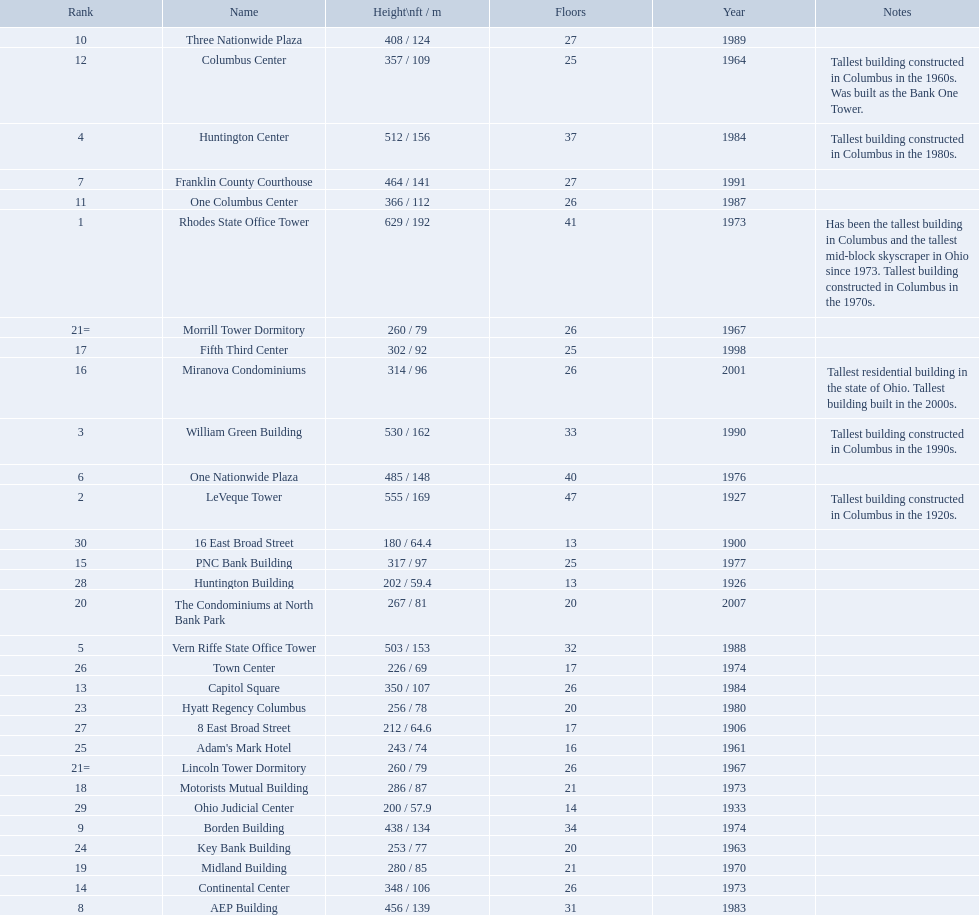What are the heights of all the buildings 629 / 192, 555 / 169, 530 / 162, 512 / 156, 503 / 153, 485 / 148, 464 / 141, 456 / 139, 438 / 134, 408 / 124, 366 / 112, 357 / 109, 350 / 107, 348 / 106, 317 / 97, 314 / 96, 302 / 92, 286 / 87, 280 / 85, 267 / 81, 260 / 79, 260 / 79, 256 / 78, 253 / 77, 243 / 74, 226 / 69, 212 / 64.6, 202 / 59.4, 200 / 57.9, 180 / 64.4. What are the heights of the aep and columbus center buildings 456 / 139, 357 / 109. Which height is greater? 456 / 139. What building is this for? AEP Building. Which of the tallest buildings in columbus, ohio were built in the 1980s? Huntington Center, Vern Riffe State Office Tower, AEP Building, Three Nationwide Plaza, One Columbus Center, Capitol Square, Hyatt Regency Columbus. Of these buildings, which have between 26 and 31 floors? AEP Building, Three Nationwide Plaza, One Columbus Center, Capitol Square. Of these buildings, which is the tallest? AEP Building. 